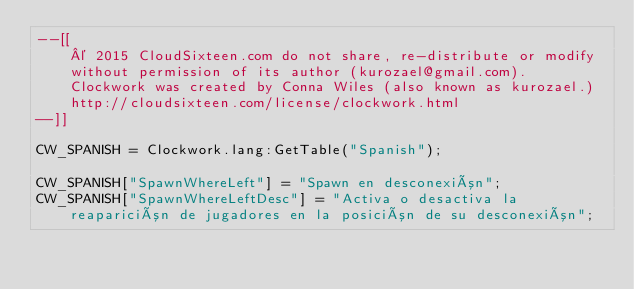<code> <loc_0><loc_0><loc_500><loc_500><_Lua_>--[[
	© 2015 CloudSixteen.com do not share, re-distribute or modify
	without permission of its author (kurozael@gmail.com).
	Clockwork was created by Conna Wiles (also known as kurozael.)
	http://cloudsixteen.com/license/clockwork.html
--]]

CW_SPANISH = Clockwork.lang:GetTable("Spanish");

CW_SPANISH["SpawnWhereLeft"] = "Spawn en desconexión";
CW_SPANISH["SpawnWhereLeftDesc"] = "Activa o desactiva la reaparición de jugadores en la posición de su desconexión";</code> 